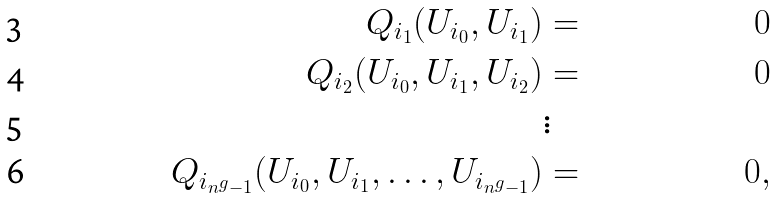Convert formula to latex. <formula><loc_0><loc_0><loc_500><loc_500>Q _ { i _ { 1 } } ( U _ { i _ { 0 } } , U _ { i _ { 1 } } ) & = & 0 \\ Q _ { i _ { 2 } } ( U _ { i _ { 0 } } , U _ { i _ { 1 } } , U _ { i _ { 2 } } ) & = & 0 \\ & \vdots & \\ Q _ { i _ { n ^ { g } - 1 } } ( U _ { i _ { 0 } } , U _ { i _ { 1 } } , \dots , U _ { i _ { n ^ { g } - 1 } } ) & = & 0 ,</formula> 